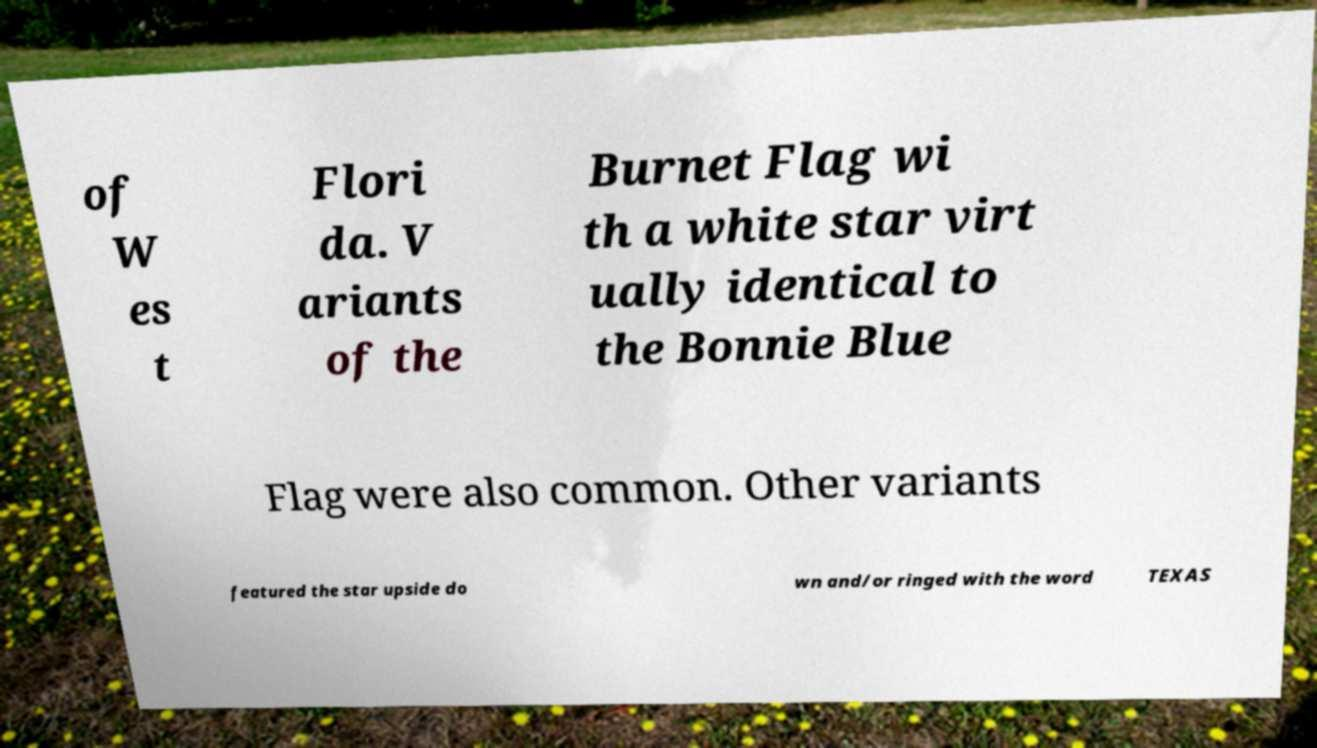Can you accurately transcribe the text from the provided image for me? of W es t Flori da. V ariants of the Burnet Flag wi th a white star virt ually identical to the Bonnie Blue Flag were also common. Other variants featured the star upside do wn and/or ringed with the word TEXAS 